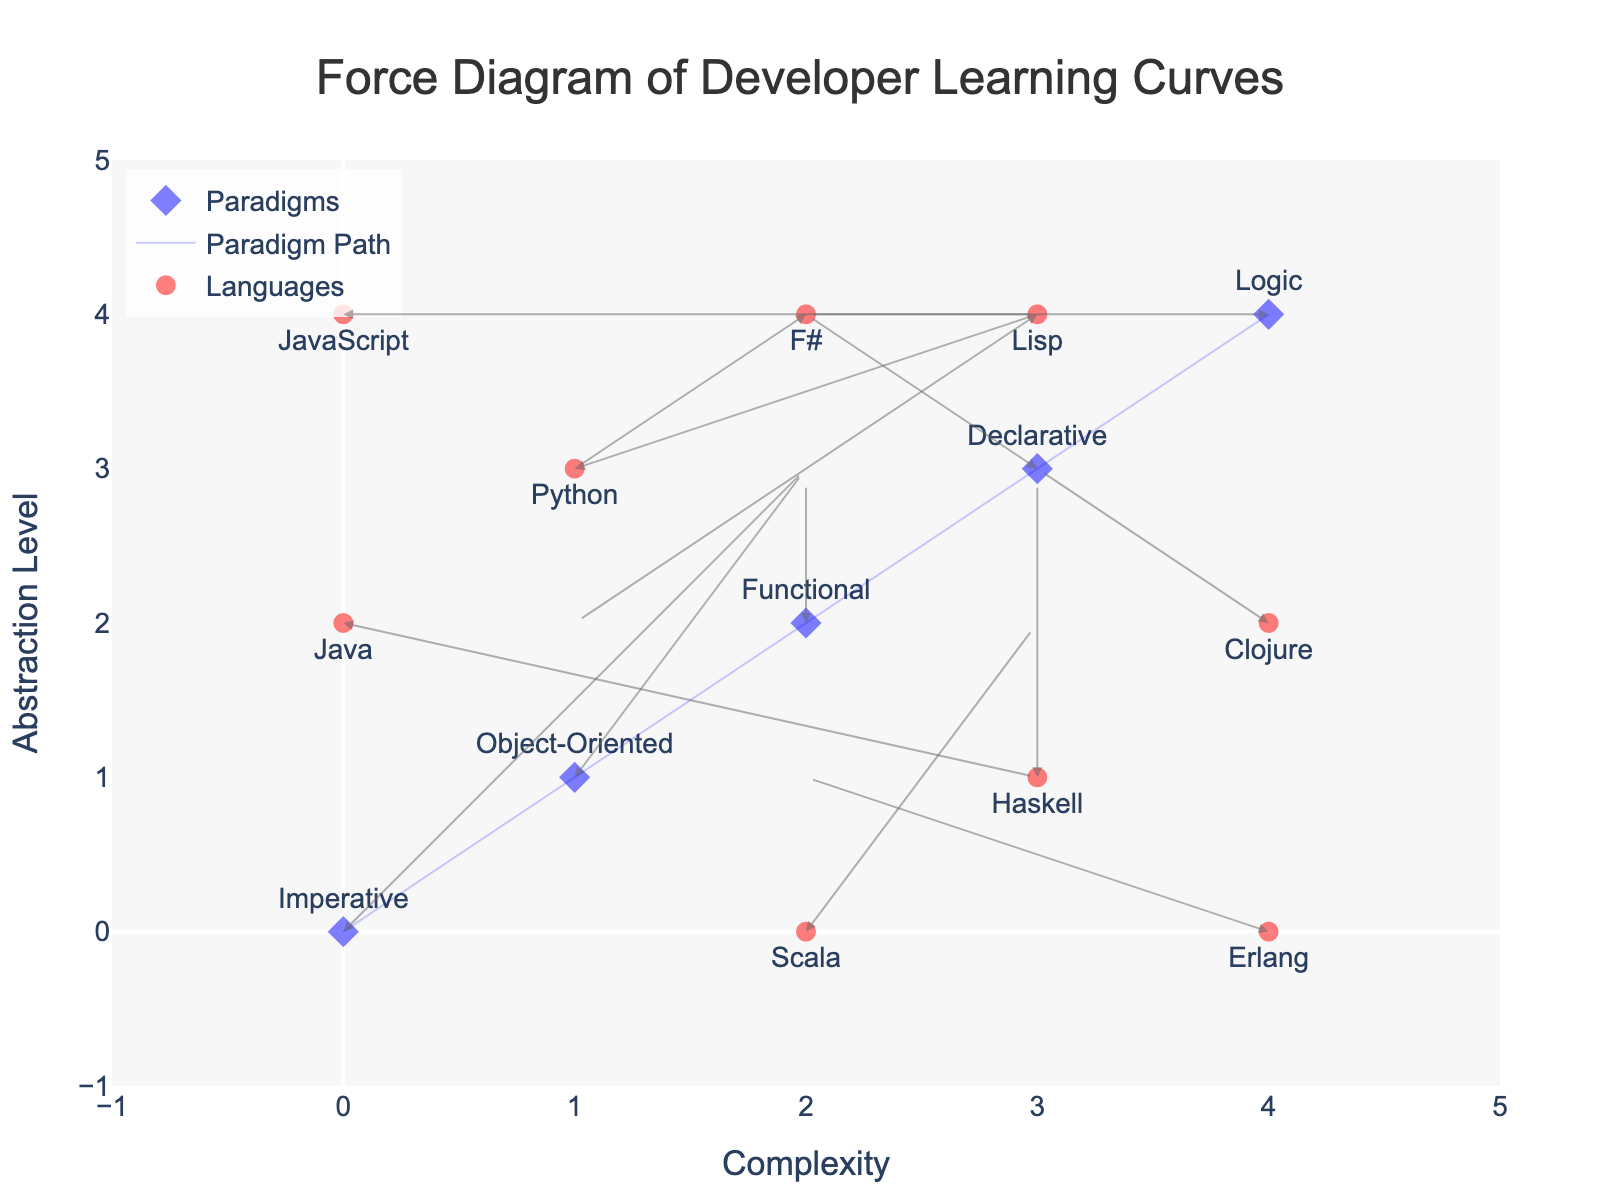What's the title of the figure? The title is at the top center of the figure, usually in larger and bold font.
Answer: Force Diagram of Developer Learning Curves What are the ranges of the x-axis and y-axis? The range of an axis is determined by checking the limits at both ends.
Answer: [-1, 5] for both axes How many paradigms are represented in the plot, and what markers are used for paradigms? Count the number of distinct paradigms and identify the marker type and color used for them. The marker for paradigms is a blue diamond.
Answer: 5 paradigms with blue diamond markers Which language has the longest arrow, and in which direction does it point? Measure the length of arrows visually or by using the vector components (u, v). The longest arrow has the largest magnitude (sqrt(u^2 + v^2)).
Answer: JavaScript, pointing rightward (3 units on x-axis) Compare the directions of the arrows for Python and F#. Which has the steeper upward direction? Check the vectors originating from the points for these languages and compare their y-components; a larger y-component implies a steeper upward direction.
Answer: Python What paradigm shows the least movement overall? Determine the paradigm with the smallest vector magnitude (sqrt(u^2 + v^2)).
Answer: Logic Which languages are associated with the functional programming paradigm, and do they move similarly compared to each other? Identify the languages under the "Functional" label and compare their directions visually or by vector components (u, v).
Answer: Haskell, Clojure, and F#. Haskell and Clojure move upwards, F# moves diagonally down-left Is there any paradigm that has arrows pointing purely in the horizontal or vertical direction? Identify if a paradigm's vector has either u or v component as 0, denoting pure horizontal or vertical direction.
Answer: Logic (horizontal) What patterns can be observed in terms of direction for the 'Imperative' and 'Declarative' paradigms? Visually track the directions of the arrows originating from these paradigms.
Answer: Imperative moves upwards and right, Declarative moves upwards Which paradigm or language is moving in the most diverse direction compared to others? Compare the vectors' directions of all entries to find the one that varies the most in direction.
Answer: JavaScript 